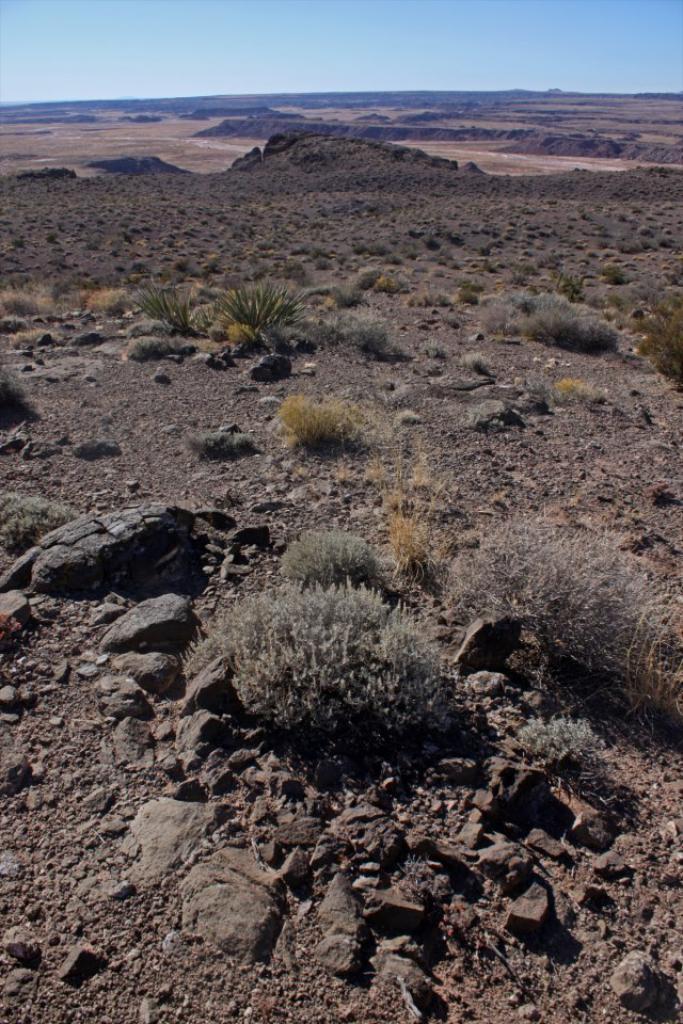Can you describe this image briefly? In this picture we can see stones and plants on the ground and in the background we can see the sky. 